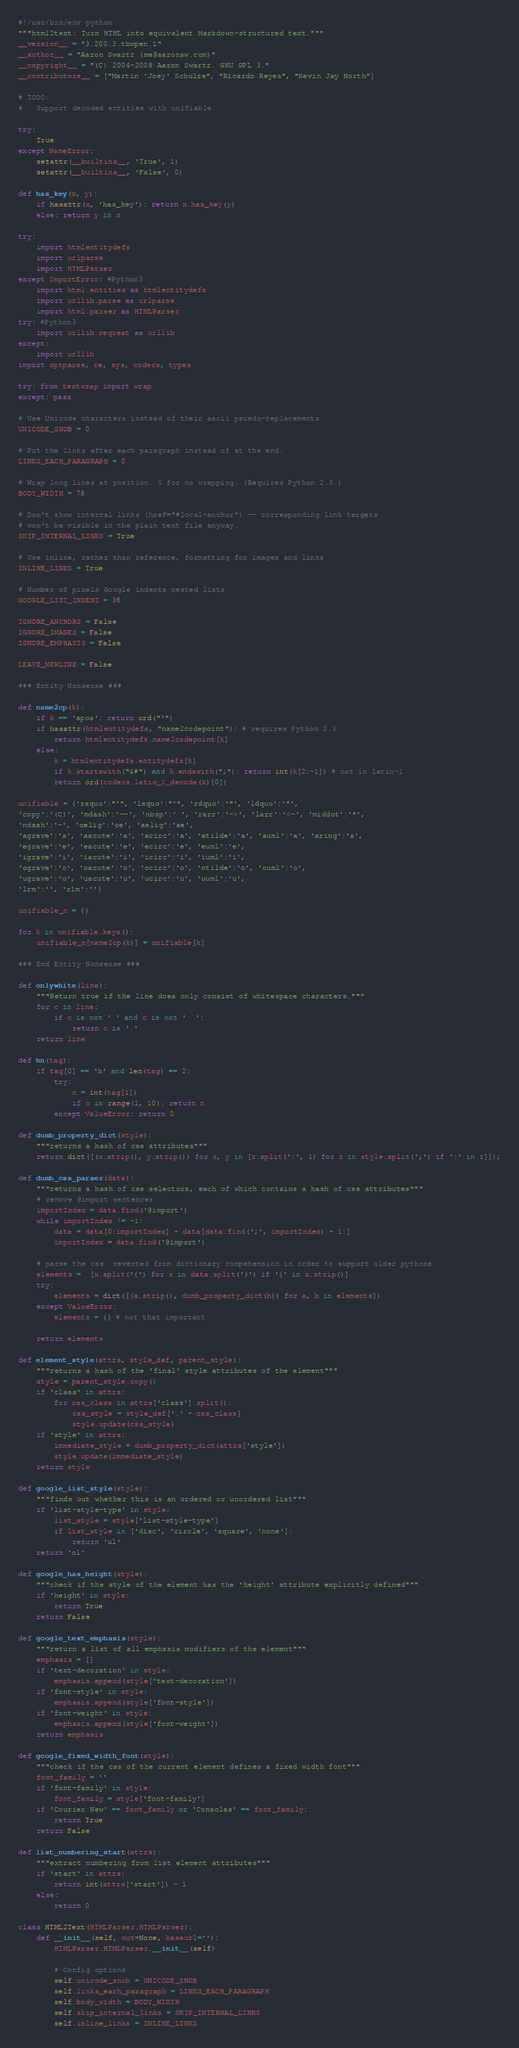Convert code to text. <code><loc_0><loc_0><loc_500><loc_500><_Python_>#!/usr/bin/env python
"""html2text: Turn HTML into equivalent Markdown-structured text."""
__version__ = "3.200.3.tbopen.1"
__author__ = "Aaron Swartz (me@aaronsw.com)"
__copyright__ = "(C) 2004-2008 Aaron Swartz. GNU GPL 3."
__contributors__ = ["Martin 'Joey' Schulze", "Ricardo Reyes", "Kevin Jay North"]

# TODO:
#   Support decoded entities with unifiable.

try:
    True
except NameError:
    setattr(__builtins__, 'True', 1)
    setattr(__builtins__, 'False', 0)

def has_key(x, y):
    if hasattr(x, 'has_key'): return x.has_key(y)
    else: return y in x

try:
    import htmlentitydefs
    import urlparse
    import HTMLParser
except ImportError: #Python3
    import html.entities as htmlentitydefs
    import urllib.parse as urlparse
    import html.parser as HTMLParser
try: #Python3
    import urllib.request as urllib
except:
    import urllib
import optparse, re, sys, codecs, types

try: from textwrap import wrap
except: pass

# Use Unicode characters instead of their ascii psuedo-replacements
UNICODE_SNOB = 0

# Put the links after each paragraph instead of at the end.
LINKS_EACH_PARAGRAPH = 0

# Wrap long lines at position. 0 for no wrapping. (Requires Python 2.3.)
BODY_WIDTH = 78

# Don't show internal links (href="#local-anchor") -- corresponding link targets
# won't be visible in the plain text file anyway.
SKIP_INTERNAL_LINKS = True

# Use inline, rather than reference, formatting for images and links
INLINE_LINKS = True

# Number of pixels Google indents nested lists
GOOGLE_LIST_INDENT = 36

IGNORE_ANCHORS = False
IGNORE_IMAGES = False
IGNORE_EMPHASIS = False

LEAVE_NEWLINE = False

### Entity Nonsense ###

def name2cp(k):
    if k == 'apos': return ord("'")
    if hasattr(htmlentitydefs, "name2codepoint"): # requires Python 2.3
        return htmlentitydefs.name2codepoint[k]
    else:
        k = htmlentitydefs.entitydefs[k]
        if k.startswith("&#") and k.endswith(";"): return int(k[2:-1]) # not in latin-1
        return ord(codecs.latin_1_decode(k)[0])

unifiable = {'rsquo':"'", 'lsquo':"'", 'rdquo':'"', 'ldquo':'"',
'copy':'(C)', 'mdash':'--', 'nbsp':' ', 'rarr':'->', 'larr':'<-', 'middot':'*',
'ndash':'-', 'oelig':'oe', 'aelig':'ae',
'agrave':'a', 'aacute':'a', 'acirc':'a', 'atilde':'a', 'auml':'a', 'aring':'a',
'egrave':'e', 'eacute':'e', 'ecirc':'e', 'euml':'e',
'igrave':'i', 'iacute':'i', 'icirc':'i', 'iuml':'i',
'ograve':'o', 'oacute':'o', 'ocirc':'o', 'otilde':'o', 'ouml':'o',
'ugrave':'u', 'uacute':'u', 'ucirc':'u', 'uuml':'u',
'lrm':'', 'rlm':''}

unifiable_n = {}

for k in unifiable.keys():
    unifiable_n[name2cp(k)] = unifiable[k]

### End Entity Nonsense ###

def onlywhite(line):
    """Return true if the line does only consist of whitespace characters."""
    for c in line:
        if c is not ' ' and c is not '  ':
            return c is ' '
    return line

def hn(tag):
    if tag[0] == 'h' and len(tag) == 2:
        try:
            n = int(tag[1])
            if n in range(1, 10): return n
        except ValueError: return 0

def dumb_property_dict(style):
    """returns a hash of css attributes"""
    return dict([(x.strip(), y.strip()) for x, y in [z.split(':', 1) for z in style.split(';') if ':' in z]]);

def dumb_css_parser(data):
    """returns a hash of css selectors, each of which contains a hash of css attributes"""
    # remove @import sentences
    importIndex = data.find('@import')
    while importIndex != -1:
        data = data[0:importIndex] + data[data.find(';', importIndex) + 1:]
        importIndex = data.find('@import')

    # parse the css. reverted from dictionary compehension in order to support older pythons
    elements =  [x.split('{') for x in data.split('}') if '{' in x.strip()]
    try:
        elements = dict([(a.strip(), dumb_property_dict(b)) for a, b in elements])
    except ValueError:
        elements = {} # not that important

    return elements

def element_style(attrs, style_def, parent_style):
    """returns a hash of the 'final' style attributes of the element"""
    style = parent_style.copy()
    if 'class' in attrs:
        for css_class in attrs['class'].split():
            css_style = style_def['.' + css_class]
            style.update(css_style)
    if 'style' in attrs:
        immediate_style = dumb_property_dict(attrs['style'])
        style.update(immediate_style)
    return style

def google_list_style(style):
    """finds out whether this is an ordered or unordered list"""
    if 'list-style-type' in style:
        list_style = style['list-style-type']
        if list_style in ['disc', 'circle', 'square', 'none']:
            return 'ul'
    return 'ol'

def google_has_height(style):
    """check if the style of the element has the 'height' attribute explicitly defined"""
    if 'height' in style:
        return True
    return False

def google_text_emphasis(style):
    """return a list of all emphasis modifiers of the element"""
    emphasis = []
    if 'text-decoration' in style:
        emphasis.append(style['text-decoration'])
    if 'font-style' in style:
        emphasis.append(style['font-style'])
    if 'font-weight' in style:
        emphasis.append(style['font-weight'])
    return emphasis

def google_fixed_width_font(style):
    """check if the css of the current element defines a fixed width font"""
    font_family = ''
    if 'font-family' in style:
        font_family = style['font-family']
    if 'Courier New' == font_family or 'Consolas' == font_family:
        return True
    return False

def list_numbering_start(attrs):
    """extract numbering from list element attributes"""
    if 'start' in attrs:
        return int(attrs['start']) - 1
    else:
        return 0

class HTML2Text(HTMLParser.HTMLParser):
    def __init__(self, out=None, baseurl=''):
        HTMLParser.HTMLParser.__init__(self)

        # Config options
        self.unicode_snob = UNICODE_SNOB
        self.links_each_paragraph = LINKS_EACH_PARAGRAPH
        self.body_width = BODY_WIDTH
        self.skip_internal_links = SKIP_INTERNAL_LINKS
        self.inline_links = INLINE_LINKS</code> 